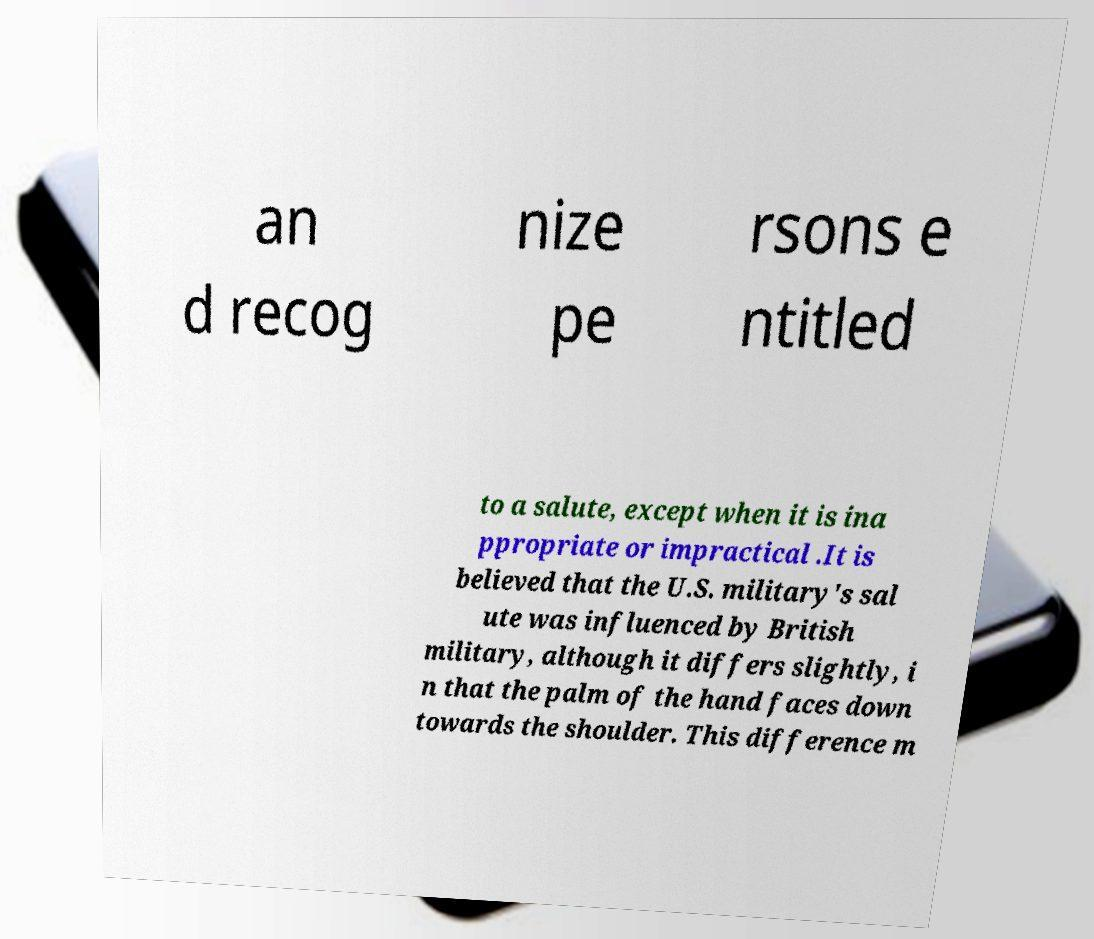What messages or text are displayed in this image? I need them in a readable, typed format. an d recog nize pe rsons e ntitled to a salute, except when it is ina ppropriate or impractical .It is believed that the U.S. military's sal ute was influenced by British military, although it differs slightly, i n that the palm of the hand faces down towards the shoulder. This difference m 